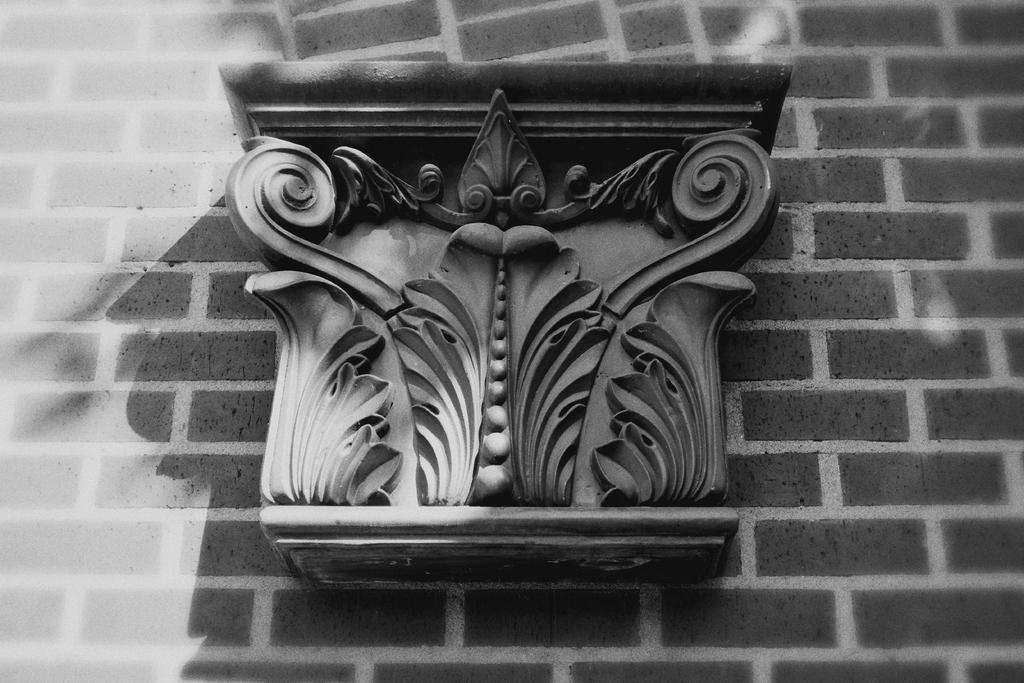What is the color scheme of the image? The image is in black and white. What can be seen on the wall in the image? There is a carving on a wall in the image. What type of produce is being sold in the image? There is no produce present in the image; it features a carving on a wall. What appliance is being used by the person in the image? There is no person or appliance present in the image; it only shows a carving on a wall. 